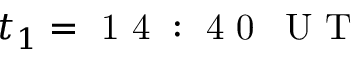Convert formula to latex. <formula><loc_0><loc_0><loc_500><loc_500>t _ { 1 } = 1 4 \colon 4 0 \, U T</formula> 